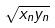Convert formula to latex. <formula><loc_0><loc_0><loc_500><loc_500>\sqrt { x _ { n } y _ { n } }</formula> 